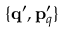Convert formula to latex. <formula><loc_0><loc_0><loc_500><loc_500>\{ { q } ^ { \prime } , { p } _ { q } ^ { \prime } \}</formula> 